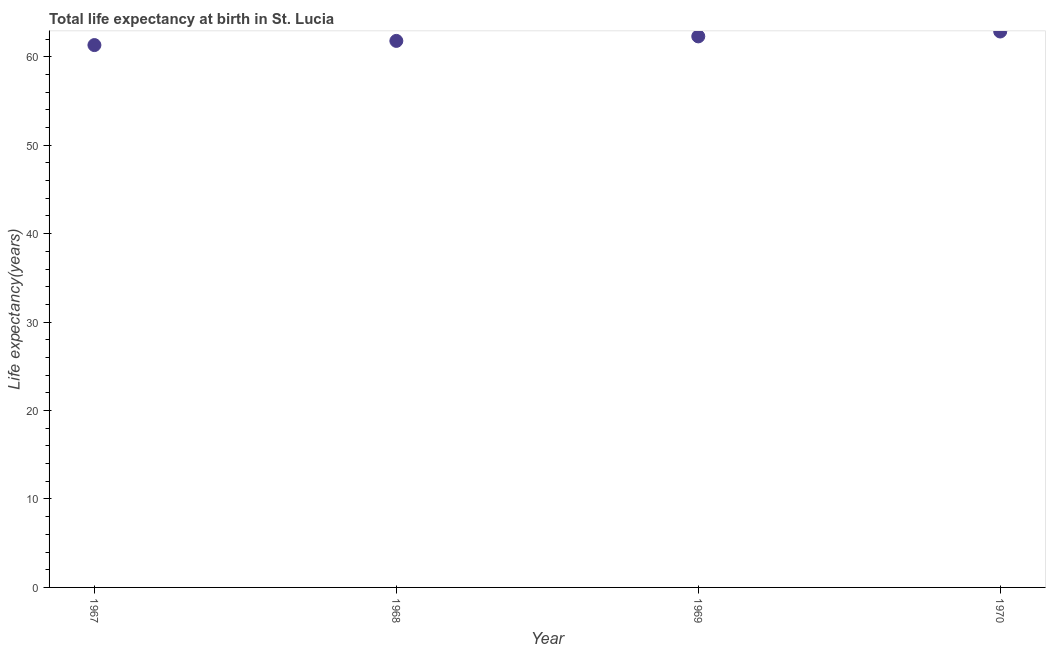What is the life expectancy at birth in 1970?
Your response must be concise. 62.85. Across all years, what is the maximum life expectancy at birth?
Provide a short and direct response. 62.85. Across all years, what is the minimum life expectancy at birth?
Your answer should be compact. 61.32. In which year was the life expectancy at birth minimum?
Offer a terse response. 1967. What is the sum of the life expectancy at birth?
Offer a very short reply. 248.26. What is the difference between the life expectancy at birth in 1967 and 1969?
Make the answer very short. -0.98. What is the average life expectancy at birth per year?
Your answer should be very brief. 62.07. What is the median life expectancy at birth?
Your response must be concise. 62.05. What is the ratio of the life expectancy at birth in 1969 to that in 1970?
Your answer should be compact. 0.99. Is the difference between the life expectancy at birth in 1967 and 1970 greater than the difference between any two years?
Offer a very short reply. Yes. What is the difference between the highest and the second highest life expectancy at birth?
Offer a terse response. 0.55. What is the difference between the highest and the lowest life expectancy at birth?
Offer a terse response. 1.53. In how many years, is the life expectancy at birth greater than the average life expectancy at birth taken over all years?
Your response must be concise. 2. Does the life expectancy at birth monotonically increase over the years?
Offer a terse response. Yes. How many years are there in the graph?
Your answer should be compact. 4. Does the graph contain grids?
Ensure brevity in your answer.  No. What is the title of the graph?
Ensure brevity in your answer.  Total life expectancy at birth in St. Lucia. What is the label or title of the X-axis?
Provide a short and direct response. Year. What is the label or title of the Y-axis?
Offer a very short reply. Life expectancy(years). What is the Life expectancy(years) in 1967?
Your response must be concise. 61.32. What is the Life expectancy(years) in 1968?
Offer a very short reply. 61.79. What is the Life expectancy(years) in 1969?
Offer a terse response. 62.3. What is the Life expectancy(years) in 1970?
Give a very brief answer. 62.85. What is the difference between the Life expectancy(years) in 1967 and 1968?
Keep it short and to the point. -0.47. What is the difference between the Life expectancy(years) in 1967 and 1969?
Provide a short and direct response. -0.98. What is the difference between the Life expectancy(years) in 1967 and 1970?
Provide a succinct answer. -1.53. What is the difference between the Life expectancy(years) in 1968 and 1969?
Keep it short and to the point. -0.51. What is the difference between the Life expectancy(years) in 1968 and 1970?
Your answer should be compact. -1.06. What is the difference between the Life expectancy(years) in 1969 and 1970?
Your answer should be compact. -0.55. What is the ratio of the Life expectancy(years) in 1967 to that in 1968?
Your answer should be very brief. 0.99. What is the ratio of the Life expectancy(years) in 1967 to that in 1969?
Keep it short and to the point. 0.98. What is the ratio of the Life expectancy(years) in 1967 to that in 1970?
Provide a succinct answer. 0.98. What is the ratio of the Life expectancy(years) in 1968 to that in 1970?
Ensure brevity in your answer.  0.98. What is the ratio of the Life expectancy(years) in 1969 to that in 1970?
Provide a succinct answer. 0.99. 